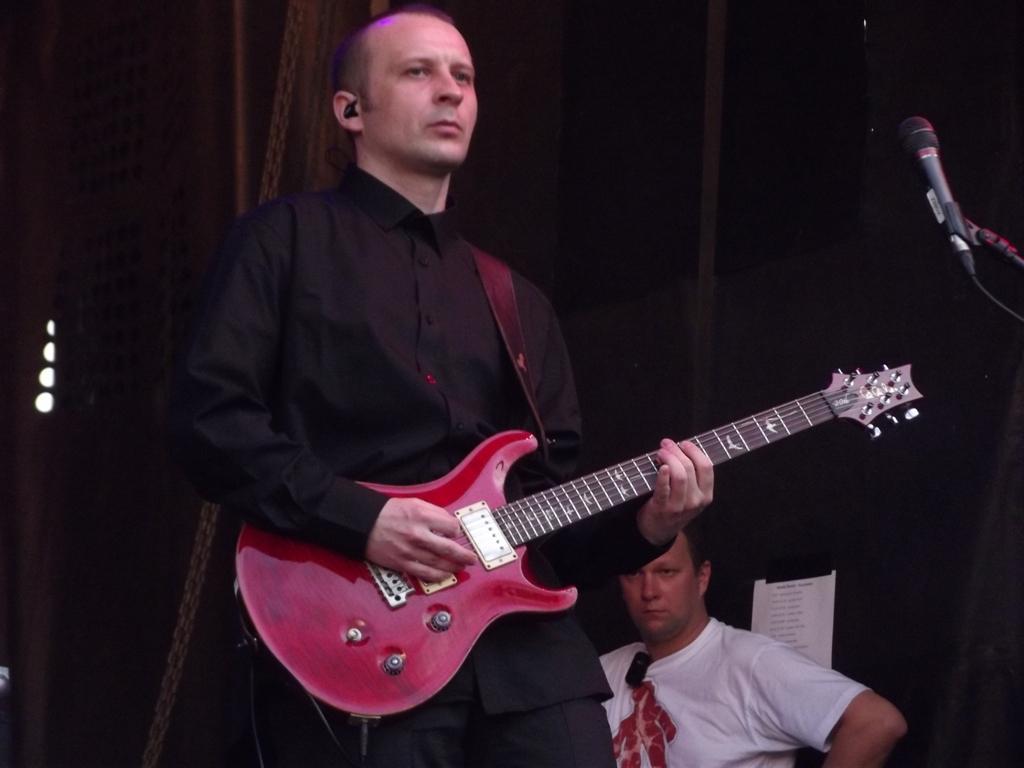Describe this image in one or two sentences. In this image I can see a man is standing and holding a guitar. In the background I can see one more person and here I can see a mic. 